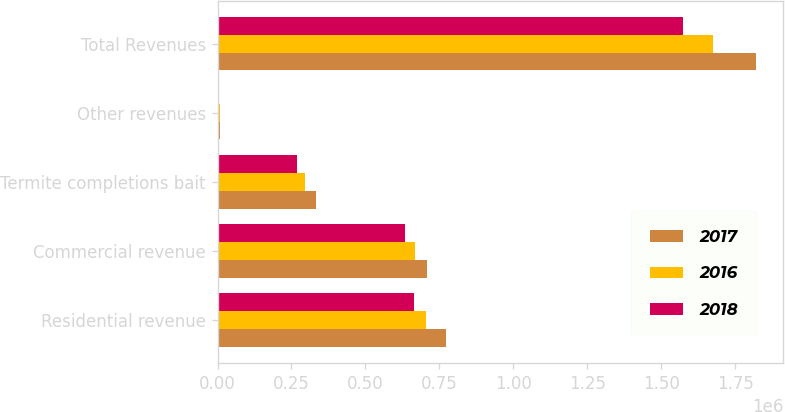Convert chart. <chart><loc_0><loc_0><loc_500><loc_500><stacked_bar_chart><ecel><fcel>Residential revenue<fcel>Commercial revenue<fcel>Termite completions bait<fcel>Other revenues<fcel>Total Revenues<nl><fcel>2017<fcel>773932<fcel>707386<fcel>332573<fcel>7674<fcel>1.82156e+06<nl><fcel>2016<fcel>705787<fcel>666523<fcel>294982<fcel>6665<fcel>1.67396e+06<nl><fcel>2018<fcel>663776<fcel>634767<fcel>269431<fcel>5503<fcel>1.57348e+06<nl></chart> 